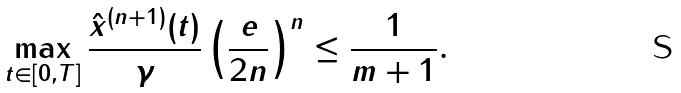Convert formula to latex. <formula><loc_0><loc_0><loc_500><loc_500>\max _ { t \in [ 0 , T ] } \frac { \| \hat { x } ^ { ( n + 1 ) } ( t ) \| } { \| \gamma \| } \left ( \frac { e } { 2 n } \right ) ^ { n } \leq \frac { 1 } { m + 1 } .</formula> 